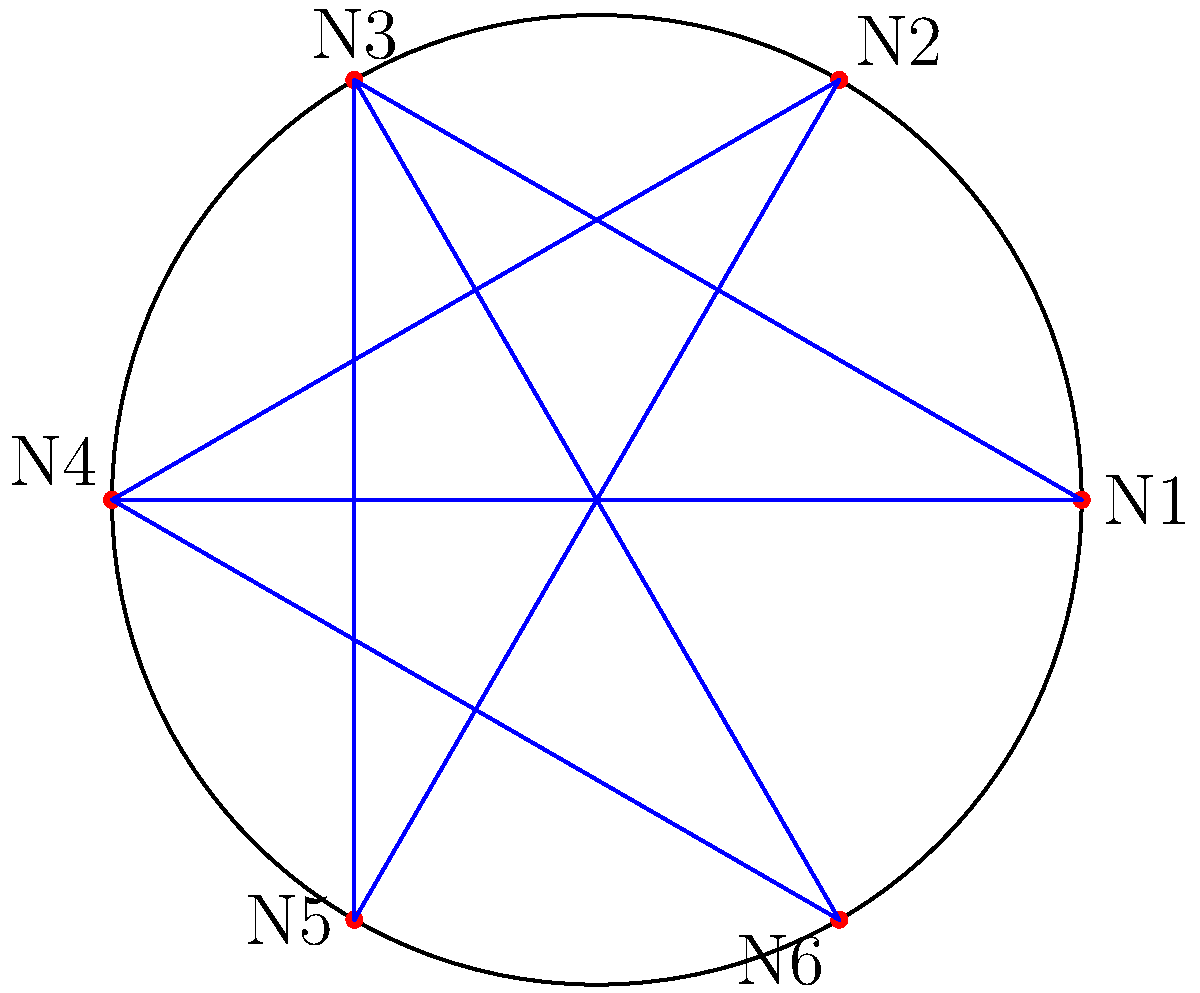In the given network topology diagram, nodes are arranged in a circular layout. If the angle between adjacent nodes is $60^\circ$, what is the polar coordinate $(r, \theta)$ of node N4, assuming N1 is at $(r, 0^\circ)$ and the radius of the circle is $r$? To find the polar coordinate of node N4, we can follow these steps:

1. Identify the position of N1: It's at $(r, 0^\circ)$.

2. Count the number of 60° intervals from N1 to N4:
   - N1 to N2: 1 interval
   - N2 to N3: 1 interval
   - N3 to N4: 1 interval
   Total: 3 intervals

3. Calculate the angle for N4:
   $\theta = 3 \times 60^\circ = 180^\circ$

4. The radius remains constant for all nodes, which is given as $r$.

5. Therefore, the polar coordinate of N4 is $(r, 180^\circ)$.

This representation allows for efficient mapping of network nodes in a circular layout, which can be useful for visualizing network topologies and planning intrusion detection systems.
Answer: $(r, 180^\circ)$ 